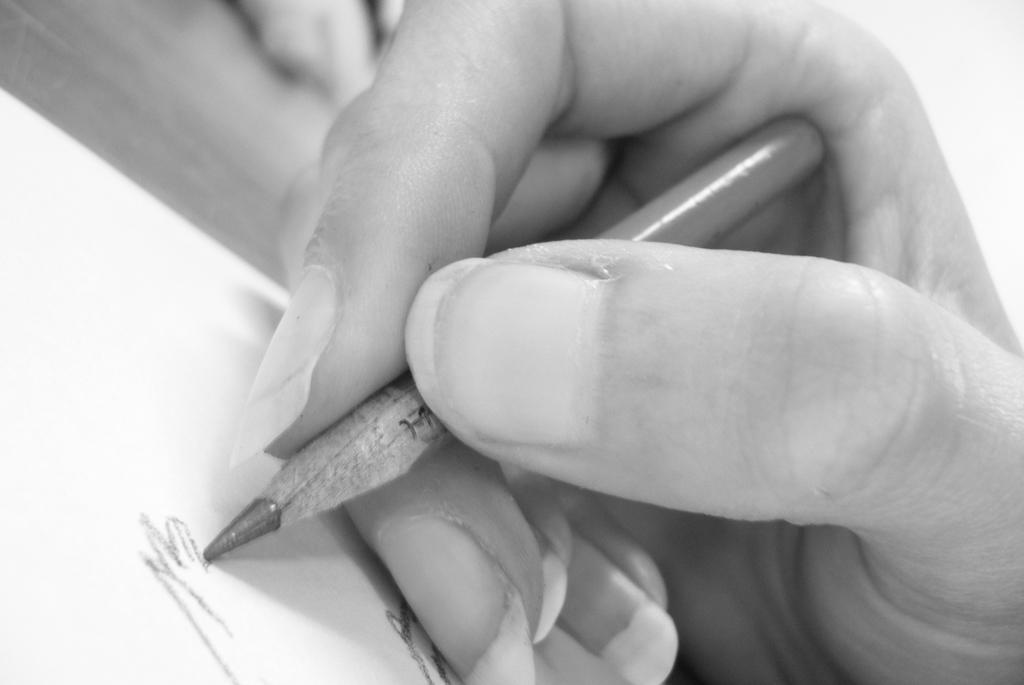Please provide a concise description of this image. This picture shows human hand holding a pencil and writing on the paper on the table. 